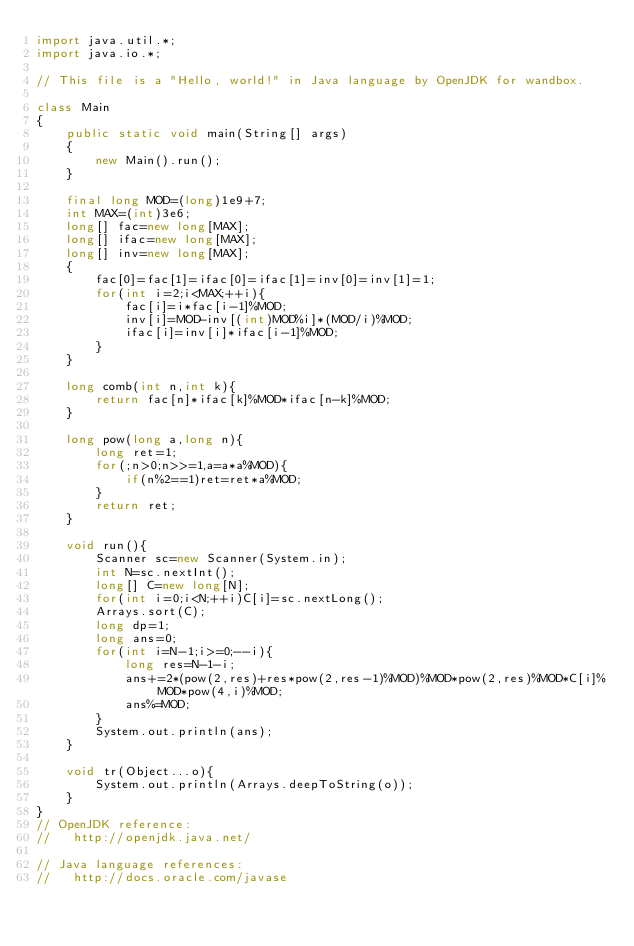<code> <loc_0><loc_0><loc_500><loc_500><_Java_>import java.util.*;
import java.io.*;

// This file is a "Hello, world!" in Java language by OpenJDK for wandbox.

class Main
{
    public static void main(String[] args)
    {
        new Main().run();
    }
	
	final long MOD=(long)1e9+7;
	int MAX=(int)3e6;
	long[] fac=new long[MAX];
	long[] ifac=new long[MAX];
	long[] inv=new long[MAX];
	{
		fac[0]=fac[1]=ifac[0]=ifac[1]=inv[0]=inv[1]=1;
		for(int i=2;i<MAX;++i){
			fac[i]=i*fac[i-1]%MOD;
			inv[i]=MOD-inv[(int)MOD%i]*(MOD/i)%MOD;
			ifac[i]=inv[i]*ifac[i-1]%MOD;
		}
	}
	
	long comb(int n,int k){
		return fac[n]*ifac[k]%MOD*ifac[n-k]%MOD;
	}
	
	long pow(long a,long n){
		long ret=1;
		for(;n>0;n>>=1,a=a*a%MOD){
			if(n%2==1)ret=ret*a%MOD;
		}
		return ret;
	}
    
    void run(){
        Scanner sc=new Scanner(System.in);
		int N=sc.nextInt();
		long[] C=new long[N];
		for(int i=0;i<N;++i)C[i]=sc.nextLong();
		Arrays.sort(C);
		long dp=1;
		long ans=0;
		for(int i=N-1;i>=0;--i){
			long res=N-1-i;
			ans+=2*(pow(2,res)+res*pow(2,res-1)%MOD)%MOD*pow(2,res)%MOD*C[i]%MOD*pow(4,i)%MOD;
			ans%=MOD;
		}
		System.out.println(ans);
    }
	
	void tr(Object...o){
		System.out.println(Arrays.deepToString(o));
	}
}
// OpenJDK reference:
//   http://openjdk.java.net/

// Java language references:
//   http://docs.oracle.com/javase
</code> 